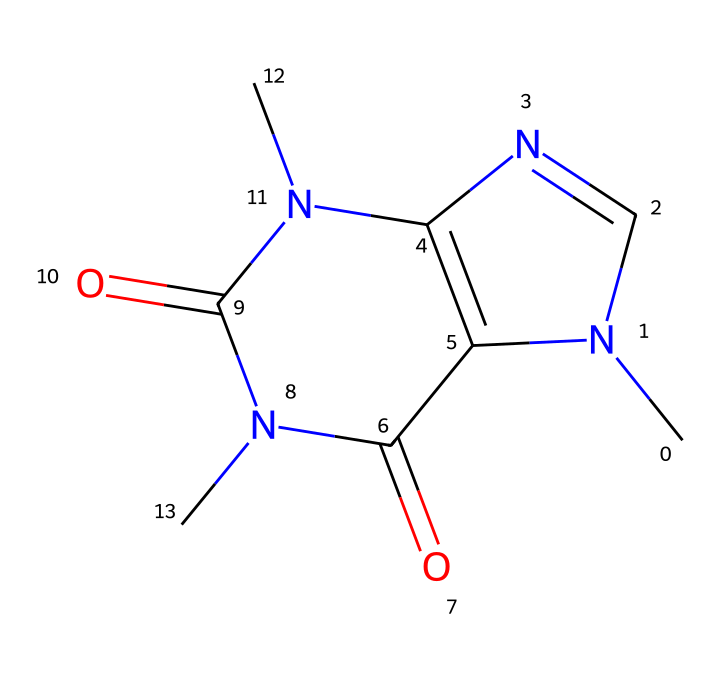how many nitrogen atoms are in the structure? By looking at the SMILES representation, count the 'N' symbols which represent nitrogen atoms. There are two 'N' symbols present.
Answer: 2 what is the functional group present in this chemical? The presence of the nitrogen atoms and their arrangement indicates that this chemical is an amide due to the carbonyl groups (C=O) adjacent to nitrogen.
Answer: amide how many total rings are in the chemical structure? The structure contains two fused rings, as indicated by the N1C and C2=C connections. Counting these gives a total of two rings.
Answer: 2 does this chemical contain double bonds? The '=' sign in the SMILES indicates the presence of double bonds. There are two '=' signs in the structure which shows that double bonds are indeed present.
Answer: yes what type of chemical is represented by this structure? The presence of carbon, nitrogen, and the specific functional groups suggest that this chemical is an alkaloid, which is a typical type of non-electrolyte.
Answer: alkaloid is this chemical soluble in water? Alkaloids are generally considered to be non-electrolytes and can have varying solubility in water based on their structure but tend to be less soluble; this specific one is predicted to have low water solubility.
Answer: low what is the molecular formula deduced from the SMILES? By analyzing the SMILES representation for each atom, you can tally up the carbon (C), hydrogen (H), nitrogen (N), and oxygen (O) atoms. The formula derived from this SMILES is C6H8N4O2.
Answer: C6H8N4O2 